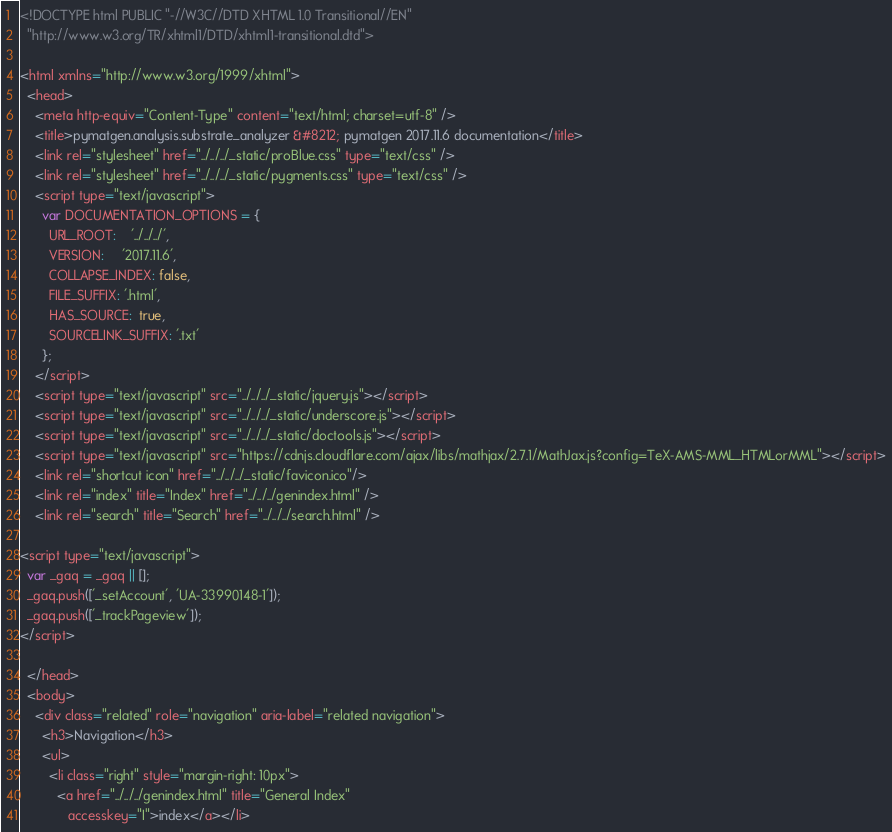Convert code to text. <code><loc_0><loc_0><loc_500><loc_500><_HTML_>
<!DOCTYPE html PUBLIC "-//W3C//DTD XHTML 1.0 Transitional//EN"
  "http://www.w3.org/TR/xhtml1/DTD/xhtml1-transitional.dtd">

<html xmlns="http://www.w3.org/1999/xhtml">
  <head>
    <meta http-equiv="Content-Type" content="text/html; charset=utf-8" />
    <title>pymatgen.analysis.substrate_analyzer &#8212; pymatgen 2017.11.6 documentation</title>
    <link rel="stylesheet" href="../../../_static/proBlue.css" type="text/css" />
    <link rel="stylesheet" href="../../../_static/pygments.css" type="text/css" />
    <script type="text/javascript">
      var DOCUMENTATION_OPTIONS = {
        URL_ROOT:    '../../../',
        VERSION:     '2017.11.6',
        COLLAPSE_INDEX: false,
        FILE_SUFFIX: '.html',
        HAS_SOURCE:  true,
        SOURCELINK_SUFFIX: '.txt'
      };
    </script>
    <script type="text/javascript" src="../../../_static/jquery.js"></script>
    <script type="text/javascript" src="../../../_static/underscore.js"></script>
    <script type="text/javascript" src="../../../_static/doctools.js"></script>
    <script type="text/javascript" src="https://cdnjs.cloudflare.com/ajax/libs/mathjax/2.7.1/MathJax.js?config=TeX-AMS-MML_HTMLorMML"></script>
    <link rel="shortcut icon" href="../../../_static/favicon.ico"/>
    <link rel="index" title="Index" href="../../../genindex.html" />
    <link rel="search" title="Search" href="../../../search.html" />
 
<script type="text/javascript">
  var _gaq = _gaq || [];
  _gaq.push(['_setAccount', 'UA-33990148-1']);
  _gaq.push(['_trackPageview']);
</script>

  </head>
  <body>
    <div class="related" role="navigation" aria-label="related navigation">
      <h3>Navigation</h3>
      <ul>
        <li class="right" style="margin-right: 10px">
          <a href="../../../genindex.html" title="General Index"
             accesskey="I">index</a></li></code> 